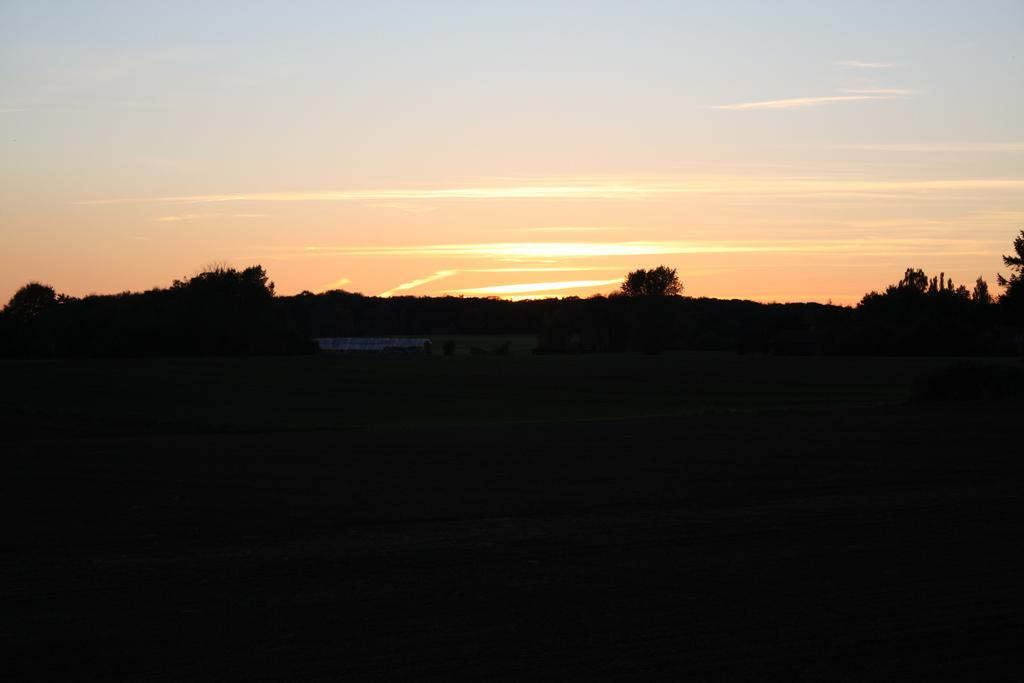What type of vegetation can be seen in the image? There are trees and plants in the image. What part of the natural environment is visible in the image? The sky is visible in the image. How many geese are flying in the image? There are no geese present in the image; it only features trees, plants, and the sky. Is there a fire visible in the image? No, there is no fire present in the image. 